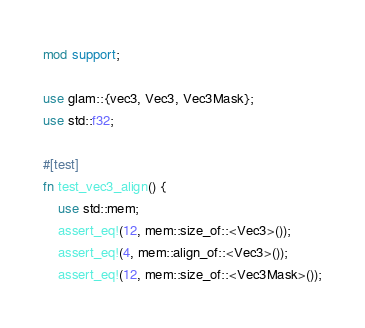Convert code to text. <code><loc_0><loc_0><loc_500><loc_500><_Rust_>mod support;

use glam::{vec3, Vec3, Vec3Mask};
use std::f32;

#[test]
fn test_vec3_align() {
    use std::mem;
    assert_eq!(12, mem::size_of::<Vec3>());
    assert_eq!(4, mem::align_of::<Vec3>());
    assert_eq!(12, mem::size_of::<Vec3Mask>());</code> 